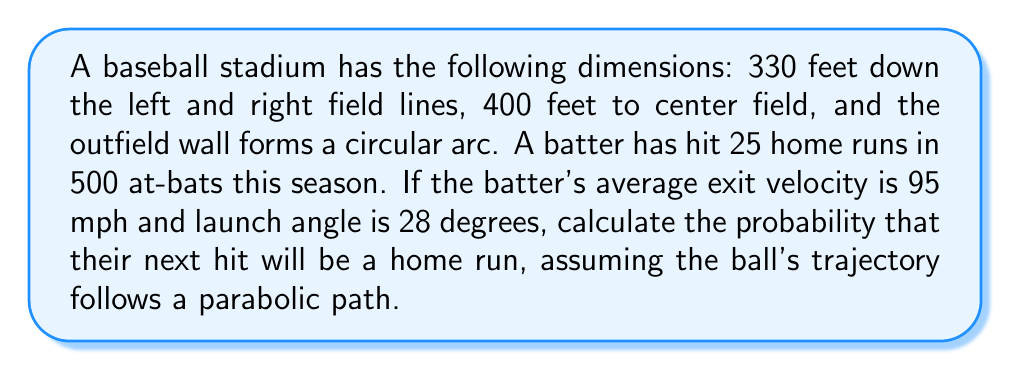Provide a solution to this math problem. To solve this problem, we'll follow these steps:

1) First, we need to calculate the area of the outfield where a home run is possible.

   The outfield forms a circular sector. We can calculate its area using the formula:
   $$A = \frac{1}{2}r^2\theta$$
   where $r$ is the radius and $\theta$ is the central angle in radians.

2) To find $r$, we can use the Pythagorean theorem:
   $$r^2 = 200^2 + 330^2 = 149,300$$
   $$r \approx 386.39 \text{ feet}$$

3) To find $\theta$, we can use the inverse cosine function:
   $$\theta = 2 \arccos(\frac{330}{386.39}) \approx 2.0944 \text{ radians}$$

4) Now we can calculate the area:
   $$A = \frac{1}{2} \cdot 386.39^2 \cdot 2.0944 \approx 155,908 \text{ sq ft}$$

5) Next, we need to calculate the distance the ball travels given the exit velocity and launch angle.
   We can use the equation:
   $$d = \frac{v^2 \sin(2\alpha)}{g}$$
   where $v$ is velocity, $\alpha$ is launch angle, and $g$ is acceleration due to gravity (32.2 ft/s^2).

6) Plugging in our values:
   $$d = \frac{(95 \cdot 1.467)^2 \sin(2 \cdot 28°)}{32.2} \approx 387.3 \text{ feet}$$

7) This distance is greater than the stadium's dimensions, so any hit with these parameters would be a home run.

8) The probability of hitting a home run is the batter's current home run rate:
   $$P(\text{HR}) = \frac{25}{500} = 0.05 = 5\%$$
Answer: The probability that the batter's next hit will be a home run is 5%. 